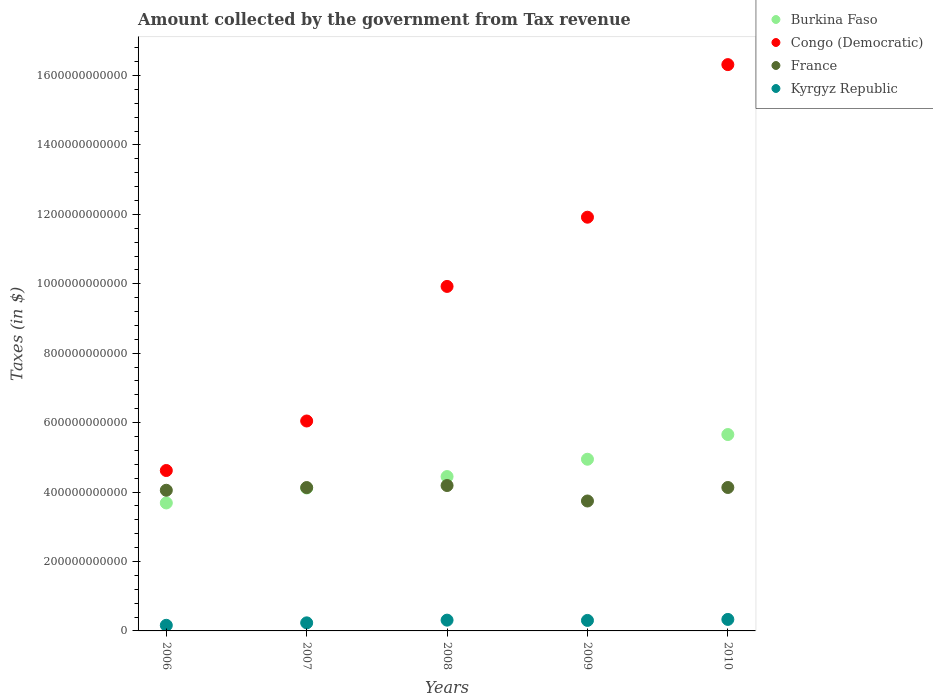How many different coloured dotlines are there?
Your answer should be compact. 4. What is the amount collected by the government from tax revenue in Congo (Democratic) in 2008?
Keep it short and to the point. 9.92e+11. Across all years, what is the maximum amount collected by the government from tax revenue in France?
Ensure brevity in your answer.  4.19e+11. Across all years, what is the minimum amount collected by the government from tax revenue in Burkina Faso?
Offer a very short reply. 3.69e+11. What is the total amount collected by the government from tax revenue in Burkina Faso in the graph?
Your response must be concise. 2.29e+12. What is the difference between the amount collected by the government from tax revenue in France in 2008 and that in 2009?
Keep it short and to the point. 4.46e+1. What is the difference between the amount collected by the government from tax revenue in Kyrgyz Republic in 2006 and the amount collected by the government from tax revenue in Burkina Faso in 2009?
Provide a succinct answer. -4.78e+11. What is the average amount collected by the government from tax revenue in Burkina Faso per year?
Provide a short and direct response. 4.57e+11. In the year 2009, what is the difference between the amount collected by the government from tax revenue in France and amount collected by the government from tax revenue in Burkina Faso?
Offer a terse response. -1.20e+11. In how many years, is the amount collected by the government from tax revenue in France greater than 960000000000 $?
Your response must be concise. 0. What is the ratio of the amount collected by the government from tax revenue in France in 2007 to that in 2008?
Make the answer very short. 0.99. What is the difference between the highest and the second highest amount collected by the government from tax revenue in Kyrgyz Republic?
Your answer should be compact. 2.09e+09. What is the difference between the highest and the lowest amount collected by the government from tax revenue in Burkina Faso?
Ensure brevity in your answer.  1.97e+11. Is it the case that in every year, the sum of the amount collected by the government from tax revenue in France and amount collected by the government from tax revenue in Congo (Democratic)  is greater than the amount collected by the government from tax revenue in Burkina Faso?
Your response must be concise. Yes. Is the amount collected by the government from tax revenue in Kyrgyz Republic strictly greater than the amount collected by the government from tax revenue in France over the years?
Your answer should be very brief. No. How many dotlines are there?
Offer a terse response. 4. What is the difference between two consecutive major ticks on the Y-axis?
Make the answer very short. 2.00e+11. Does the graph contain any zero values?
Your response must be concise. No. Does the graph contain grids?
Keep it short and to the point. No. Where does the legend appear in the graph?
Offer a terse response. Top right. What is the title of the graph?
Your response must be concise. Amount collected by the government from Tax revenue. What is the label or title of the X-axis?
Give a very brief answer. Years. What is the label or title of the Y-axis?
Give a very brief answer. Taxes (in $). What is the Taxes (in $) in Burkina Faso in 2006?
Provide a short and direct response. 3.69e+11. What is the Taxes (in $) in Congo (Democratic) in 2006?
Give a very brief answer. 4.62e+11. What is the Taxes (in $) in France in 2006?
Your answer should be compact. 4.05e+11. What is the Taxes (in $) of Kyrgyz Republic in 2006?
Make the answer very short. 1.62e+1. What is the Taxes (in $) in Burkina Faso in 2007?
Ensure brevity in your answer.  4.12e+11. What is the Taxes (in $) in Congo (Democratic) in 2007?
Ensure brevity in your answer.  6.05e+11. What is the Taxes (in $) in France in 2007?
Make the answer very short. 4.13e+11. What is the Taxes (in $) in Kyrgyz Republic in 2007?
Ensure brevity in your answer.  2.33e+1. What is the Taxes (in $) of Burkina Faso in 2008?
Offer a terse response. 4.45e+11. What is the Taxes (in $) of Congo (Democratic) in 2008?
Offer a terse response. 9.92e+11. What is the Taxes (in $) in France in 2008?
Offer a terse response. 4.19e+11. What is the Taxes (in $) of Kyrgyz Republic in 2008?
Offer a terse response. 3.10e+1. What is the Taxes (in $) in Burkina Faso in 2009?
Ensure brevity in your answer.  4.95e+11. What is the Taxes (in $) in Congo (Democratic) in 2009?
Keep it short and to the point. 1.19e+12. What is the Taxes (in $) of France in 2009?
Your answer should be compact. 3.74e+11. What is the Taxes (in $) in Kyrgyz Republic in 2009?
Your response must be concise. 3.03e+1. What is the Taxes (in $) in Burkina Faso in 2010?
Offer a terse response. 5.66e+11. What is the Taxes (in $) of Congo (Democratic) in 2010?
Provide a short and direct response. 1.63e+12. What is the Taxes (in $) of France in 2010?
Offer a very short reply. 4.13e+11. What is the Taxes (in $) in Kyrgyz Republic in 2010?
Your answer should be very brief. 3.31e+1. Across all years, what is the maximum Taxes (in $) in Burkina Faso?
Your response must be concise. 5.66e+11. Across all years, what is the maximum Taxes (in $) in Congo (Democratic)?
Ensure brevity in your answer.  1.63e+12. Across all years, what is the maximum Taxes (in $) in France?
Give a very brief answer. 4.19e+11. Across all years, what is the maximum Taxes (in $) in Kyrgyz Republic?
Your answer should be compact. 3.31e+1. Across all years, what is the minimum Taxes (in $) of Burkina Faso?
Ensure brevity in your answer.  3.69e+11. Across all years, what is the minimum Taxes (in $) in Congo (Democratic)?
Offer a terse response. 4.62e+11. Across all years, what is the minimum Taxes (in $) of France?
Give a very brief answer. 3.74e+11. Across all years, what is the minimum Taxes (in $) of Kyrgyz Republic?
Offer a very short reply. 1.62e+1. What is the total Taxes (in $) of Burkina Faso in the graph?
Your answer should be very brief. 2.29e+12. What is the total Taxes (in $) of Congo (Democratic) in the graph?
Make the answer very short. 4.88e+12. What is the total Taxes (in $) in France in the graph?
Ensure brevity in your answer.  2.02e+12. What is the total Taxes (in $) of Kyrgyz Republic in the graph?
Provide a short and direct response. 1.34e+11. What is the difference between the Taxes (in $) in Burkina Faso in 2006 and that in 2007?
Provide a succinct answer. -4.30e+1. What is the difference between the Taxes (in $) in Congo (Democratic) in 2006 and that in 2007?
Keep it short and to the point. -1.43e+11. What is the difference between the Taxes (in $) of France in 2006 and that in 2007?
Make the answer very short. -7.79e+09. What is the difference between the Taxes (in $) of Kyrgyz Republic in 2006 and that in 2007?
Your answer should be compact. -7.09e+09. What is the difference between the Taxes (in $) in Burkina Faso in 2006 and that in 2008?
Offer a very short reply. -7.60e+1. What is the difference between the Taxes (in $) in Congo (Democratic) in 2006 and that in 2008?
Provide a short and direct response. -5.30e+11. What is the difference between the Taxes (in $) of France in 2006 and that in 2008?
Provide a short and direct response. -1.37e+1. What is the difference between the Taxes (in $) of Kyrgyz Republic in 2006 and that in 2008?
Your answer should be compact. -1.49e+1. What is the difference between the Taxes (in $) of Burkina Faso in 2006 and that in 2009?
Ensure brevity in your answer.  -1.26e+11. What is the difference between the Taxes (in $) of Congo (Democratic) in 2006 and that in 2009?
Offer a terse response. -7.30e+11. What is the difference between the Taxes (in $) of France in 2006 and that in 2009?
Provide a short and direct response. 3.09e+1. What is the difference between the Taxes (in $) in Kyrgyz Republic in 2006 and that in 2009?
Make the answer very short. -1.41e+1. What is the difference between the Taxes (in $) in Burkina Faso in 2006 and that in 2010?
Offer a very short reply. -1.97e+11. What is the difference between the Taxes (in $) in Congo (Democratic) in 2006 and that in 2010?
Make the answer very short. -1.17e+12. What is the difference between the Taxes (in $) of France in 2006 and that in 2010?
Keep it short and to the point. -8.03e+09. What is the difference between the Taxes (in $) of Kyrgyz Republic in 2006 and that in 2010?
Offer a terse response. -1.69e+1. What is the difference between the Taxes (in $) in Burkina Faso in 2007 and that in 2008?
Offer a very short reply. -3.30e+1. What is the difference between the Taxes (in $) in Congo (Democratic) in 2007 and that in 2008?
Your response must be concise. -3.88e+11. What is the difference between the Taxes (in $) in France in 2007 and that in 2008?
Your answer should be very brief. -5.90e+09. What is the difference between the Taxes (in $) of Kyrgyz Republic in 2007 and that in 2008?
Give a very brief answer. -7.77e+09. What is the difference between the Taxes (in $) of Burkina Faso in 2007 and that in 2009?
Keep it short and to the point. -8.29e+1. What is the difference between the Taxes (in $) of Congo (Democratic) in 2007 and that in 2009?
Provide a succinct answer. -5.87e+11. What is the difference between the Taxes (in $) in France in 2007 and that in 2009?
Your answer should be very brief. 3.87e+1. What is the difference between the Taxes (in $) of Kyrgyz Republic in 2007 and that in 2009?
Keep it short and to the point. -6.99e+09. What is the difference between the Taxes (in $) of Burkina Faso in 2007 and that in 2010?
Keep it short and to the point. -1.54e+11. What is the difference between the Taxes (in $) in Congo (Democratic) in 2007 and that in 2010?
Give a very brief answer. -1.03e+12. What is the difference between the Taxes (in $) of France in 2007 and that in 2010?
Ensure brevity in your answer.  -2.44e+08. What is the difference between the Taxes (in $) of Kyrgyz Republic in 2007 and that in 2010?
Ensure brevity in your answer.  -9.86e+09. What is the difference between the Taxes (in $) in Burkina Faso in 2008 and that in 2009?
Give a very brief answer. -4.99e+1. What is the difference between the Taxes (in $) of Congo (Democratic) in 2008 and that in 2009?
Make the answer very short. -1.99e+11. What is the difference between the Taxes (in $) of France in 2008 and that in 2009?
Provide a succinct answer. 4.46e+1. What is the difference between the Taxes (in $) of Kyrgyz Republic in 2008 and that in 2009?
Keep it short and to the point. 7.79e+08. What is the difference between the Taxes (in $) in Burkina Faso in 2008 and that in 2010?
Offer a terse response. -1.21e+11. What is the difference between the Taxes (in $) in Congo (Democratic) in 2008 and that in 2010?
Offer a terse response. -6.39e+11. What is the difference between the Taxes (in $) of France in 2008 and that in 2010?
Ensure brevity in your answer.  5.66e+09. What is the difference between the Taxes (in $) of Kyrgyz Republic in 2008 and that in 2010?
Ensure brevity in your answer.  -2.09e+09. What is the difference between the Taxes (in $) in Burkina Faso in 2009 and that in 2010?
Provide a short and direct response. -7.12e+1. What is the difference between the Taxes (in $) in Congo (Democratic) in 2009 and that in 2010?
Your response must be concise. -4.40e+11. What is the difference between the Taxes (in $) of France in 2009 and that in 2010?
Offer a very short reply. -3.89e+1. What is the difference between the Taxes (in $) of Kyrgyz Republic in 2009 and that in 2010?
Ensure brevity in your answer.  -2.87e+09. What is the difference between the Taxes (in $) of Burkina Faso in 2006 and the Taxes (in $) of Congo (Democratic) in 2007?
Ensure brevity in your answer.  -2.36e+11. What is the difference between the Taxes (in $) of Burkina Faso in 2006 and the Taxes (in $) of France in 2007?
Provide a short and direct response. -4.43e+1. What is the difference between the Taxes (in $) of Burkina Faso in 2006 and the Taxes (in $) of Kyrgyz Republic in 2007?
Make the answer very short. 3.45e+11. What is the difference between the Taxes (in $) of Congo (Democratic) in 2006 and the Taxes (in $) of France in 2007?
Offer a terse response. 4.91e+1. What is the difference between the Taxes (in $) of Congo (Democratic) in 2006 and the Taxes (in $) of Kyrgyz Republic in 2007?
Make the answer very short. 4.39e+11. What is the difference between the Taxes (in $) of France in 2006 and the Taxes (in $) of Kyrgyz Republic in 2007?
Your answer should be very brief. 3.82e+11. What is the difference between the Taxes (in $) in Burkina Faso in 2006 and the Taxes (in $) in Congo (Democratic) in 2008?
Give a very brief answer. -6.24e+11. What is the difference between the Taxes (in $) in Burkina Faso in 2006 and the Taxes (in $) in France in 2008?
Make the answer very short. -5.02e+1. What is the difference between the Taxes (in $) in Burkina Faso in 2006 and the Taxes (in $) in Kyrgyz Republic in 2008?
Provide a succinct answer. 3.38e+11. What is the difference between the Taxes (in $) in Congo (Democratic) in 2006 and the Taxes (in $) in France in 2008?
Keep it short and to the point. 4.32e+1. What is the difference between the Taxes (in $) of Congo (Democratic) in 2006 and the Taxes (in $) of Kyrgyz Republic in 2008?
Ensure brevity in your answer.  4.31e+11. What is the difference between the Taxes (in $) in France in 2006 and the Taxes (in $) in Kyrgyz Republic in 2008?
Your answer should be compact. 3.74e+11. What is the difference between the Taxes (in $) of Burkina Faso in 2006 and the Taxes (in $) of Congo (Democratic) in 2009?
Keep it short and to the point. -8.23e+11. What is the difference between the Taxes (in $) in Burkina Faso in 2006 and the Taxes (in $) in France in 2009?
Your answer should be very brief. -5.60e+09. What is the difference between the Taxes (in $) in Burkina Faso in 2006 and the Taxes (in $) in Kyrgyz Republic in 2009?
Ensure brevity in your answer.  3.38e+11. What is the difference between the Taxes (in $) of Congo (Democratic) in 2006 and the Taxes (in $) of France in 2009?
Make the answer very short. 8.78e+1. What is the difference between the Taxes (in $) in Congo (Democratic) in 2006 and the Taxes (in $) in Kyrgyz Republic in 2009?
Make the answer very short. 4.32e+11. What is the difference between the Taxes (in $) of France in 2006 and the Taxes (in $) of Kyrgyz Republic in 2009?
Your answer should be very brief. 3.75e+11. What is the difference between the Taxes (in $) in Burkina Faso in 2006 and the Taxes (in $) in Congo (Democratic) in 2010?
Ensure brevity in your answer.  -1.26e+12. What is the difference between the Taxes (in $) in Burkina Faso in 2006 and the Taxes (in $) in France in 2010?
Ensure brevity in your answer.  -4.45e+1. What is the difference between the Taxes (in $) in Burkina Faso in 2006 and the Taxes (in $) in Kyrgyz Republic in 2010?
Give a very brief answer. 3.36e+11. What is the difference between the Taxes (in $) in Congo (Democratic) in 2006 and the Taxes (in $) in France in 2010?
Ensure brevity in your answer.  4.89e+1. What is the difference between the Taxes (in $) of Congo (Democratic) in 2006 and the Taxes (in $) of Kyrgyz Republic in 2010?
Make the answer very short. 4.29e+11. What is the difference between the Taxes (in $) of France in 2006 and the Taxes (in $) of Kyrgyz Republic in 2010?
Ensure brevity in your answer.  3.72e+11. What is the difference between the Taxes (in $) in Burkina Faso in 2007 and the Taxes (in $) in Congo (Democratic) in 2008?
Offer a terse response. -5.81e+11. What is the difference between the Taxes (in $) of Burkina Faso in 2007 and the Taxes (in $) of France in 2008?
Provide a short and direct response. -7.17e+09. What is the difference between the Taxes (in $) of Burkina Faso in 2007 and the Taxes (in $) of Kyrgyz Republic in 2008?
Offer a terse response. 3.81e+11. What is the difference between the Taxes (in $) in Congo (Democratic) in 2007 and the Taxes (in $) in France in 2008?
Your response must be concise. 1.86e+11. What is the difference between the Taxes (in $) in Congo (Democratic) in 2007 and the Taxes (in $) in Kyrgyz Republic in 2008?
Your answer should be compact. 5.74e+11. What is the difference between the Taxes (in $) in France in 2007 and the Taxes (in $) in Kyrgyz Republic in 2008?
Give a very brief answer. 3.82e+11. What is the difference between the Taxes (in $) of Burkina Faso in 2007 and the Taxes (in $) of Congo (Democratic) in 2009?
Give a very brief answer. -7.80e+11. What is the difference between the Taxes (in $) of Burkina Faso in 2007 and the Taxes (in $) of France in 2009?
Your answer should be very brief. 3.74e+1. What is the difference between the Taxes (in $) in Burkina Faso in 2007 and the Taxes (in $) in Kyrgyz Republic in 2009?
Provide a succinct answer. 3.81e+11. What is the difference between the Taxes (in $) of Congo (Democratic) in 2007 and the Taxes (in $) of France in 2009?
Make the answer very short. 2.30e+11. What is the difference between the Taxes (in $) of Congo (Democratic) in 2007 and the Taxes (in $) of Kyrgyz Republic in 2009?
Provide a succinct answer. 5.74e+11. What is the difference between the Taxes (in $) in France in 2007 and the Taxes (in $) in Kyrgyz Republic in 2009?
Give a very brief answer. 3.83e+11. What is the difference between the Taxes (in $) in Burkina Faso in 2007 and the Taxes (in $) in Congo (Democratic) in 2010?
Your answer should be compact. -1.22e+12. What is the difference between the Taxes (in $) in Burkina Faso in 2007 and the Taxes (in $) in France in 2010?
Your response must be concise. -1.52e+09. What is the difference between the Taxes (in $) in Burkina Faso in 2007 and the Taxes (in $) in Kyrgyz Republic in 2010?
Give a very brief answer. 3.79e+11. What is the difference between the Taxes (in $) of Congo (Democratic) in 2007 and the Taxes (in $) of France in 2010?
Make the answer very short. 1.92e+11. What is the difference between the Taxes (in $) of Congo (Democratic) in 2007 and the Taxes (in $) of Kyrgyz Republic in 2010?
Offer a terse response. 5.72e+11. What is the difference between the Taxes (in $) of France in 2007 and the Taxes (in $) of Kyrgyz Republic in 2010?
Ensure brevity in your answer.  3.80e+11. What is the difference between the Taxes (in $) of Burkina Faso in 2008 and the Taxes (in $) of Congo (Democratic) in 2009?
Offer a very short reply. -7.47e+11. What is the difference between the Taxes (in $) of Burkina Faso in 2008 and the Taxes (in $) of France in 2009?
Your response must be concise. 7.04e+1. What is the difference between the Taxes (in $) of Burkina Faso in 2008 and the Taxes (in $) of Kyrgyz Republic in 2009?
Offer a terse response. 4.14e+11. What is the difference between the Taxes (in $) in Congo (Democratic) in 2008 and the Taxes (in $) in France in 2009?
Your answer should be compact. 6.18e+11. What is the difference between the Taxes (in $) in Congo (Democratic) in 2008 and the Taxes (in $) in Kyrgyz Republic in 2009?
Provide a short and direct response. 9.62e+11. What is the difference between the Taxes (in $) in France in 2008 and the Taxes (in $) in Kyrgyz Republic in 2009?
Keep it short and to the point. 3.89e+11. What is the difference between the Taxes (in $) of Burkina Faso in 2008 and the Taxes (in $) of Congo (Democratic) in 2010?
Your answer should be very brief. -1.19e+12. What is the difference between the Taxes (in $) of Burkina Faso in 2008 and the Taxes (in $) of France in 2010?
Offer a very short reply. 3.15e+1. What is the difference between the Taxes (in $) of Burkina Faso in 2008 and the Taxes (in $) of Kyrgyz Republic in 2010?
Give a very brief answer. 4.12e+11. What is the difference between the Taxes (in $) in Congo (Democratic) in 2008 and the Taxes (in $) in France in 2010?
Ensure brevity in your answer.  5.79e+11. What is the difference between the Taxes (in $) of Congo (Democratic) in 2008 and the Taxes (in $) of Kyrgyz Republic in 2010?
Provide a short and direct response. 9.59e+11. What is the difference between the Taxes (in $) in France in 2008 and the Taxes (in $) in Kyrgyz Republic in 2010?
Offer a very short reply. 3.86e+11. What is the difference between the Taxes (in $) in Burkina Faso in 2009 and the Taxes (in $) in Congo (Democratic) in 2010?
Keep it short and to the point. -1.14e+12. What is the difference between the Taxes (in $) in Burkina Faso in 2009 and the Taxes (in $) in France in 2010?
Offer a very short reply. 8.14e+1. What is the difference between the Taxes (in $) in Burkina Faso in 2009 and the Taxes (in $) in Kyrgyz Republic in 2010?
Offer a terse response. 4.61e+11. What is the difference between the Taxes (in $) of Congo (Democratic) in 2009 and the Taxes (in $) of France in 2010?
Offer a very short reply. 7.79e+11. What is the difference between the Taxes (in $) in Congo (Democratic) in 2009 and the Taxes (in $) in Kyrgyz Republic in 2010?
Provide a short and direct response. 1.16e+12. What is the difference between the Taxes (in $) in France in 2009 and the Taxes (in $) in Kyrgyz Republic in 2010?
Your answer should be compact. 3.41e+11. What is the average Taxes (in $) of Burkina Faso per year?
Offer a very short reply. 4.57e+11. What is the average Taxes (in $) of Congo (Democratic) per year?
Your response must be concise. 9.76e+11. What is the average Taxes (in $) of France per year?
Your answer should be very brief. 4.05e+11. What is the average Taxes (in $) in Kyrgyz Republic per year?
Your answer should be compact. 2.68e+1. In the year 2006, what is the difference between the Taxes (in $) of Burkina Faso and Taxes (in $) of Congo (Democratic)?
Provide a succinct answer. -9.34e+1. In the year 2006, what is the difference between the Taxes (in $) of Burkina Faso and Taxes (in $) of France?
Give a very brief answer. -3.65e+1. In the year 2006, what is the difference between the Taxes (in $) of Burkina Faso and Taxes (in $) of Kyrgyz Republic?
Give a very brief answer. 3.52e+11. In the year 2006, what is the difference between the Taxes (in $) in Congo (Democratic) and Taxes (in $) in France?
Your answer should be very brief. 5.69e+1. In the year 2006, what is the difference between the Taxes (in $) in Congo (Democratic) and Taxes (in $) in Kyrgyz Republic?
Offer a terse response. 4.46e+11. In the year 2006, what is the difference between the Taxes (in $) in France and Taxes (in $) in Kyrgyz Republic?
Your answer should be very brief. 3.89e+11. In the year 2007, what is the difference between the Taxes (in $) of Burkina Faso and Taxes (in $) of Congo (Democratic)?
Your answer should be compact. -1.93e+11. In the year 2007, what is the difference between the Taxes (in $) in Burkina Faso and Taxes (in $) in France?
Your answer should be compact. -1.28e+09. In the year 2007, what is the difference between the Taxes (in $) of Burkina Faso and Taxes (in $) of Kyrgyz Republic?
Keep it short and to the point. 3.88e+11. In the year 2007, what is the difference between the Taxes (in $) of Congo (Democratic) and Taxes (in $) of France?
Offer a very short reply. 1.92e+11. In the year 2007, what is the difference between the Taxes (in $) in Congo (Democratic) and Taxes (in $) in Kyrgyz Republic?
Your answer should be very brief. 5.81e+11. In the year 2007, what is the difference between the Taxes (in $) in France and Taxes (in $) in Kyrgyz Republic?
Make the answer very short. 3.90e+11. In the year 2008, what is the difference between the Taxes (in $) in Burkina Faso and Taxes (in $) in Congo (Democratic)?
Give a very brief answer. -5.48e+11. In the year 2008, what is the difference between the Taxes (in $) in Burkina Faso and Taxes (in $) in France?
Your response must be concise. 2.58e+1. In the year 2008, what is the difference between the Taxes (in $) in Burkina Faso and Taxes (in $) in Kyrgyz Republic?
Your response must be concise. 4.14e+11. In the year 2008, what is the difference between the Taxes (in $) in Congo (Democratic) and Taxes (in $) in France?
Offer a very short reply. 5.74e+11. In the year 2008, what is the difference between the Taxes (in $) in Congo (Democratic) and Taxes (in $) in Kyrgyz Republic?
Your answer should be very brief. 9.61e+11. In the year 2008, what is the difference between the Taxes (in $) of France and Taxes (in $) of Kyrgyz Republic?
Ensure brevity in your answer.  3.88e+11. In the year 2009, what is the difference between the Taxes (in $) of Burkina Faso and Taxes (in $) of Congo (Democratic)?
Keep it short and to the point. -6.97e+11. In the year 2009, what is the difference between the Taxes (in $) in Burkina Faso and Taxes (in $) in France?
Keep it short and to the point. 1.20e+11. In the year 2009, what is the difference between the Taxes (in $) in Burkina Faso and Taxes (in $) in Kyrgyz Republic?
Give a very brief answer. 4.64e+11. In the year 2009, what is the difference between the Taxes (in $) in Congo (Democratic) and Taxes (in $) in France?
Give a very brief answer. 8.18e+11. In the year 2009, what is the difference between the Taxes (in $) of Congo (Democratic) and Taxes (in $) of Kyrgyz Republic?
Offer a very short reply. 1.16e+12. In the year 2009, what is the difference between the Taxes (in $) of France and Taxes (in $) of Kyrgyz Republic?
Ensure brevity in your answer.  3.44e+11. In the year 2010, what is the difference between the Taxes (in $) of Burkina Faso and Taxes (in $) of Congo (Democratic)?
Keep it short and to the point. -1.07e+12. In the year 2010, what is the difference between the Taxes (in $) in Burkina Faso and Taxes (in $) in France?
Provide a succinct answer. 1.53e+11. In the year 2010, what is the difference between the Taxes (in $) in Burkina Faso and Taxes (in $) in Kyrgyz Republic?
Offer a very short reply. 5.33e+11. In the year 2010, what is the difference between the Taxes (in $) in Congo (Democratic) and Taxes (in $) in France?
Make the answer very short. 1.22e+12. In the year 2010, what is the difference between the Taxes (in $) of Congo (Democratic) and Taxes (in $) of Kyrgyz Republic?
Your response must be concise. 1.60e+12. In the year 2010, what is the difference between the Taxes (in $) of France and Taxes (in $) of Kyrgyz Republic?
Make the answer very short. 3.80e+11. What is the ratio of the Taxes (in $) of Burkina Faso in 2006 to that in 2007?
Provide a short and direct response. 0.9. What is the ratio of the Taxes (in $) in Congo (Democratic) in 2006 to that in 2007?
Your response must be concise. 0.76. What is the ratio of the Taxes (in $) of France in 2006 to that in 2007?
Make the answer very short. 0.98. What is the ratio of the Taxes (in $) in Kyrgyz Republic in 2006 to that in 2007?
Give a very brief answer. 0.7. What is the ratio of the Taxes (in $) in Burkina Faso in 2006 to that in 2008?
Provide a short and direct response. 0.83. What is the ratio of the Taxes (in $) of Congo (Democratic) in 2006 to that in 2008?
Provide a short and direct response. 0.47. What is the ratio of the Taxes (in $) in France in 2006 to that in 2008?
Provide a short and direct response. 0.97. What is the ratio of the Taxes (in $) in Kyrgyz Republic in 2006 to that in 2008?
Offer a terse response. 0.52. What is the ratio of the Taxes (in $) in Burkina Faso in 2006 to that in 2009?
Make the answer very short. 0.75. What is the ratio of the Taxes (in $) of Congo (Democratic) in 2006 to that in 2009?
Ensure brevity in your answer.  0.39. What is the ratio of the Taxes (in $) of France in 2006 to that in 2009?
Your response must be concise. 1.08. What is the ratio of the Taxes (in $) of Kyrgyz Republic in 2006 to that in 2009?
Ensure brevity in your answer.  0.53. What is the ratio of the Taxes (in $) in Burkina Faso in 2006 to that in 2010?
Offer a terse response. 0.65. What is the ratio of the Taxes (in $) of Congo (Democratic) in 2006 to that in 2010?
Keep it short and to the point. 0.28. What is the ratio of the Taxes (in $) of France in 2006 to that in 2010?
Make the answer very short. 0.98. What is the ratio of the Taxes (in $) in Kyrgyz Republic in 2006 to that in 2010?
Offer a terse response. 0.49. What is the ratio of the Taxes (in $) of Burkina Faso in 2007 to that in 2008?
Your answer should be very brief. 0.93. What is the ratio of the Taxes (in $) of Congo (Democratic) in 2007 to that in 2008?
Provide a succinct answer. 0.61. What is the ratio of the Taxes (in $) in France in 2007 to that in 2008?
Give a very brief answer. 0.99. What is the ratio of the Taxes (in $) of Kyrgyz Republic in 2007 to that in 2008?
Offer a very short reply. 0.75. What is the ratio of the Taxes (in $) of Burkina Faso in 2007 to that in 2009?
Your response must be concise. 0.83. What is the ratio of the Taxes (in $) of Congo (Democratic) in 2007 to that in 2009?
Offer a very short reply. 0.51. What is the ratio of the Taxes (in $) of France in 2007 to that in 2009?
Make the answer very short. 1.1. What is the ratio of the Taxes (in $) of Kyrgyz Republic in 2007 to that in 2009?
Keep it short and to the point. 0.77. What is the ratio of the Taxes (in $) in Burkina Faso in 2007 to that in 2010?
Offer a terse response. 0.73. What is the ratio of the Taxes (in $) of Congo (Democratic) in 2007 to that in 2010?
Give a very brief answer. 0.37. What is the ratio of the Taxes (in $) of Kyrgyz Republic in 2007 to that in 2010?
Give a very brief answer. 0.7. What is the ratio of the Taxes (in $) in Burkina Faso in 2008 to that in 2009?
Keep it short and to the point. 0.9. What is the ratio of the Taxes (in $) of Congo (Democratic) in 2008 to that in 2009?
Offer a very short reply. 0.83. What is the ratio of the Taxes (in $) in France in 2008 to that in 2009?
Keep it short and to the point. 1.12. What is the ratio of the Taxes (in $) in Kyrgyz Republic in 2008 to that in 2009?
Give a very brief answer. 1.03. What is the ratio of the Taxes (in $) in Burkina Faso in 2008 to that in 2010?
Ensure brevity in your answer.  0.79. What is the ratio of the Taxes (in $) in Congo (Democratic) in 2008 to that in 2010?
Ensure brevity in your answer.  0.61. What is the ratio of the Taxes (in $) in France in 2008 to that in 2010?
Provide a succinct answer. 1.01. What is the ratio of the Taxes (in $) in Kyrgyz Republic in 2008 to that in 2010?
Provide a succinct answer. 0.94. What is the ratio of the Taxes (in $) of Burkina Faso in 2009 to that in 2010?
Provide a short and direct response. 0.87. What is the ratio of the Taxes (in $) in Congo (Democratic) in 2009 to that in 2010?
Offer a very short reply. 0.73. What is the ratio of the Taxes (in $) in France in 2009 to that in 2010?
Make the answer very short. 0.91. What is the ratio of the Taxes (in $) in Kyrgyz Republic in 2009 to that in 2010?
Give a very brief answer. 0.91. What is the difference between the highest and the second highest Taxes (in $) of Burkina Faso?
Provide a succinct answer. 7.12e+1. What is the difference between the highest and the second highest Taxes (in $) of Congo (Democratic)?
Keep it short and to the point. 4.40e+11. What is the difference between the highest and the second highest Taxes (in $) of France?
Provide a short and direct response. 5.66e+09. What is the difference between the highest and the second highest Taxes (in $) of Kyrgyz Republic?
Offer a very short reply. 2.09e+09. What is the difference between the highest and the lowest Taxes (in $) in Burkina Faso?
Keep it short and to the point. 1.97e+11. What is the difference between the highest and the lowest Taxes (in $) in Congo (Democratic)?
Your answer should be very brief. 1.17e+12. What is the difference between the highest and the lowest Taxes (in $) of France?
Ensure brevity in your answer.  4.46e+1. What is the difference between the highest and the lowest Taxes (in $) of Kyrgyz Republic?
Offer a terse response. 1.69e+1. 